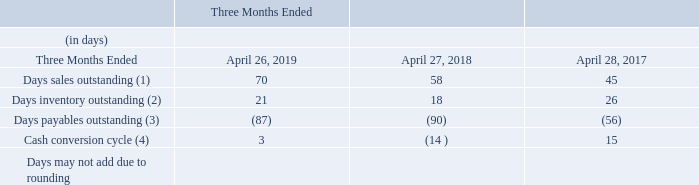Cash Conversion Cycle
The following table presents the components of our cash conversion cycle for the fourth quarter of each of the past three fiscal years:
(1) Days sales outstanding, referred to as DSO, calculates the average collection period of our receivables. DSO is based on ending accounts receivable and net revenue for each period. DSO is calculated by dividing accounts receivable by average net revenue per day for the current quarter (91 days for each of the fourth quarters presented above). The year over year increases in DSO in the fourth quarter of fiscal 2019 and fiscal 2018 were primarily due to less favorable shipping linearity and, in the case of fiscal 2019, one of our major distributors choosing not to take advantage of an early payment discount.
(2) Days inventory outstanding, referred to as DIO, measures the average number of days from procurement to sale of our products. DIO is based on ending inventory and cost of revenues for each period. DIO is calculated by dividing ending inventory by average cost of revenues per day for the current quarter. The increase in DIO in the fourth quarter of fiscal 2019 compared to the corresponding period of fiscal 2018 was primarily due to higher levels of finished goods on hand at the end of fiscal 2019. Compared to the corresponding period in fiscal 2017, the decrease in DIO in the fourth quarter of fiscal 2018 was due primarily to strong product sales towards the end of the fourth quarter of fiscal 2018.
(3) Days payables outstanding, referred to as DPO, calculates the average number of days our payables remain outstanding before payment. DPO is based on ending accounts payable and cost of revenues for each period. DPO is calculated by dividing accounts payable by average cost of revenues per day for the current quarter. DPO for the fourth quarter of fiscal 2019 was relatively unchanged compared to the fourth quarter of fiscal 2018, while it increased compared to the corresponding period in fiscal 2017 was primarily the result of improved vendor payables management and extensions of payment terms with our suppliers.
(4) The cash conversion cycle is the sum of DSO and DIO less DPO. Items which may cause the cash conversion cycle in a particular period to differ include, but are not limited to, changes in business mix, changes in payment terms (including extended payment terms from suppliers), the extent of shipment linearity, seasonal trends and the timing of revenue recognition and inventory purchases within the period.
How was Days sales outstanding calculated? Dividing accounts receivable by average net revenue per day for the current quarter (91 days for each of the fourth quarters presented above). What was days inventory outstanding based on? Ending inventory and cost of revenues for each period. What was the Days sales outstanding for three months ended april 2019? 70. What was the change in day sales outstanding between 2018 and 2019? 70-58
Answer: 12. How many years did days inventory outstanding exceed 20 days? 2019##2017
Answer: 2. What was the total percentage change in the cash conversion cycle between 2017 and 2019?
Answer scale should be: percent. (3-15)/15
Answer: -80. 